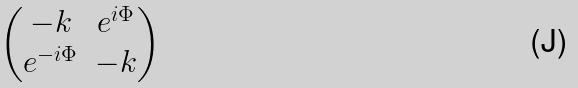<formula> <loc_0><loc_0><loc_500><loc_500>\begin{pmatrix} - k & e ^ { i \Phi } \\ e ^ { - i \Phi } & - k \end{pmatrix}</formula> 